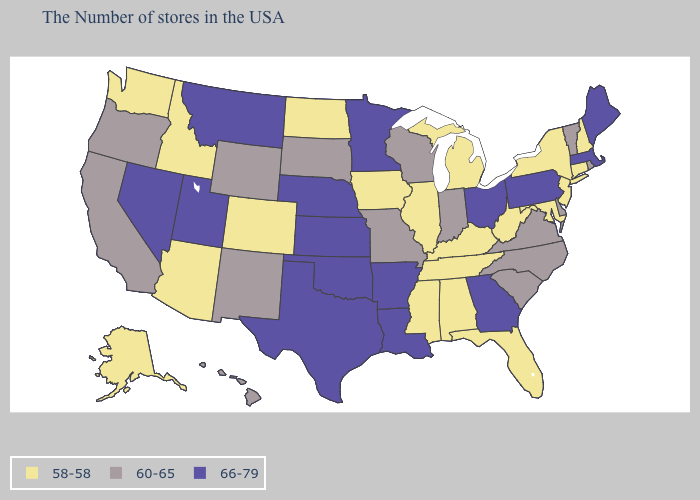What is the lowest value in the MidWest?
Be succinct. 58-58. Does Nebraska have the lowest value in the USA?
Quick response, please. No. Does the first symbol in the legend represent the smallest category?
Quick response, please. Yes. How many symbols are there in the legend?
Write a very short answer. 3. What is the value of Idaho?
Answer briefly. 58-58. Does Massachusetts have the lowest value in the USA?
Write a very short answer. No. Among the states that border Vermont , which have the highest value?
Quick response, please. Massachusetts. Name the states that have a value in the range 66-79?
Keep it brief. Maine, Massachusetts, Pennsylvania, Ohio, Georgia, Louisiana, Arkansas, Minnesota, Kansas, Nebraska, Oklahoma, Texas, Utah, Montana, Nevada. Does the first symbol in the legend represent the smallest category?
Be succinct. Yes. Does Illinois have the same value as Rhode Island?
Quick response, please. No. Among the states that border Georgia , does Tennessee have the lowest value?
Answer briefly. Yes. Name the states that have a value in the range 66-79?
Quick response, please. Maine, Massachusetts, Pennsylvania, Ohio, Georgia, Louisiana, Arkansas, Minnesota, Kansas, Nebraska, Oklahoma, Texas, Utah, Montana, Nevada. Name the states that have a value in the range 60-65?
Keep it brief. Rhode Island, Vermont, Delaware, Virginia, North Carolina, South Carolina, Indiana, Wisconsin, Missouri, South Dakota, Wyoming, New Mexico, California, Oregon, Hawaii. What is the value of Minnesota?
Answer briefly. 66-79. Does New York have the lowest value in the Northeast?
Short answer required. Yes. 